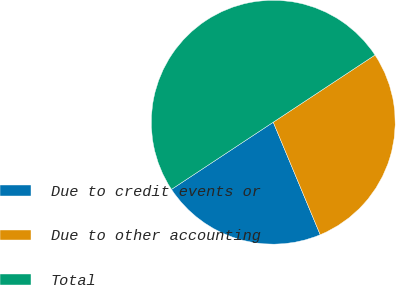<chart> <loc_0><loc_0><loc_500><loc_500><pie_chart><fcel>Due to credit events or<fcel>Due to other accounting<fcel>Total<nl><fcel>22.01%<fcel>27.99%<fcel>50.0%<nl></chart> 